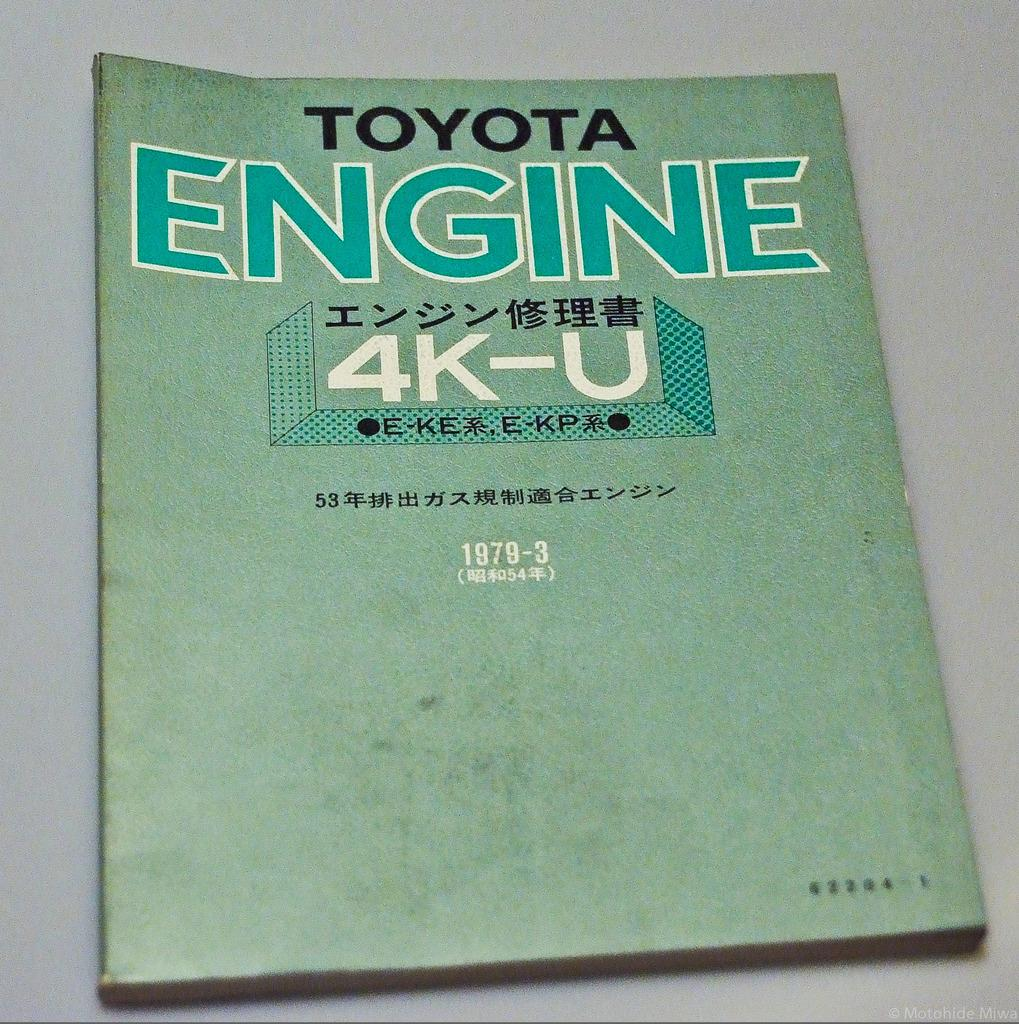<image>
Create a compact narrative representing the image presented. a book that says 'toyota engine' at the top of it 